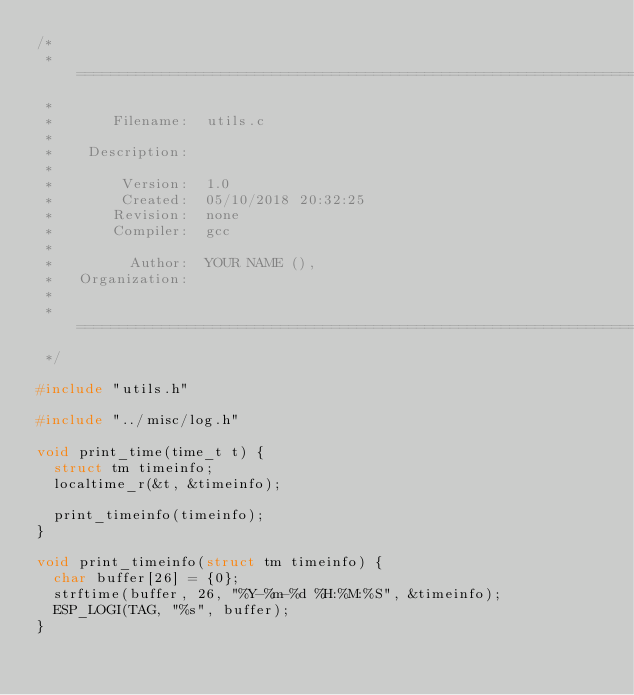Convert code to text. <code><loc_0><loc_0><loc_500><loc_500><_C_>/*
 * =====================================================================================
 *
 *       Filename:  utils.c
 *
 *    Description:  
 *
 *        Version:  1.0
 *        Created:  05/10/2018 20:32:25
 *       Revision:  none
 *       Compiler:  gcc
 *
 *         Author:  YOUR NAME (), 
 *   Organization:  
 *
 * =====================================================================================
 */

#include "utils.h"

#include "../misc/log.h"

void print_time(time_t t) {
  struct tm timeinfo;
  localtime_r(&t, &timeinfo); 

  print_timeinfo(timeinfo);
}

void print_timeinfo(struct tm timeinfo) {
  char buffer[26] = {0};
  strftime(buffer, 26, "%Y-%m-%d %H:%M:%S", &timeinfo);
  ESP_LOGI(TAG, "%s", buffer);
}
</code> 